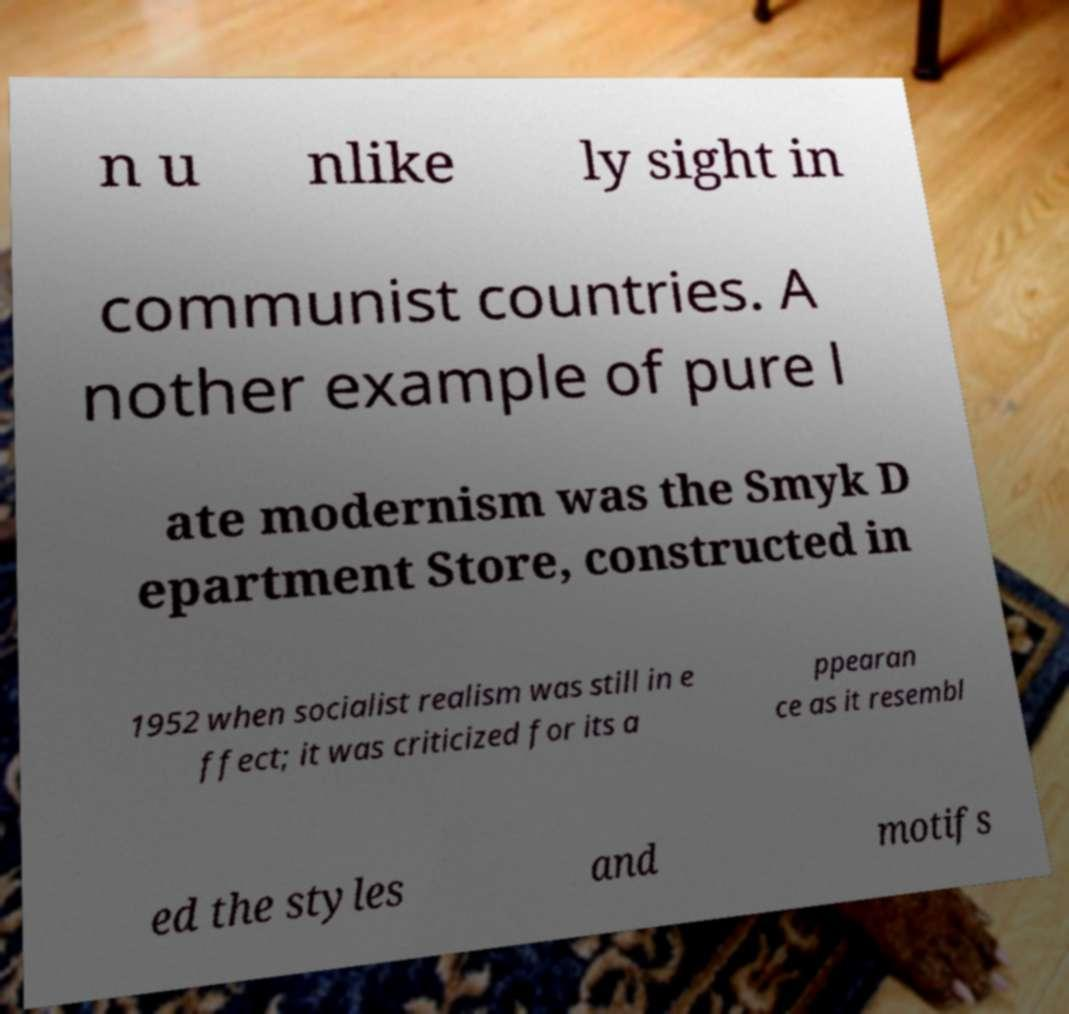Could you extract and type out the text from this image? n u nlike ly sight in communist countries. A nother example of pure l ate modernism was the Smyk D epartment Store, constructed in 1952 when socialist realism was still in e ffect; it was criticized for its a ppearan ce as it resembl ed the styles and motifs 